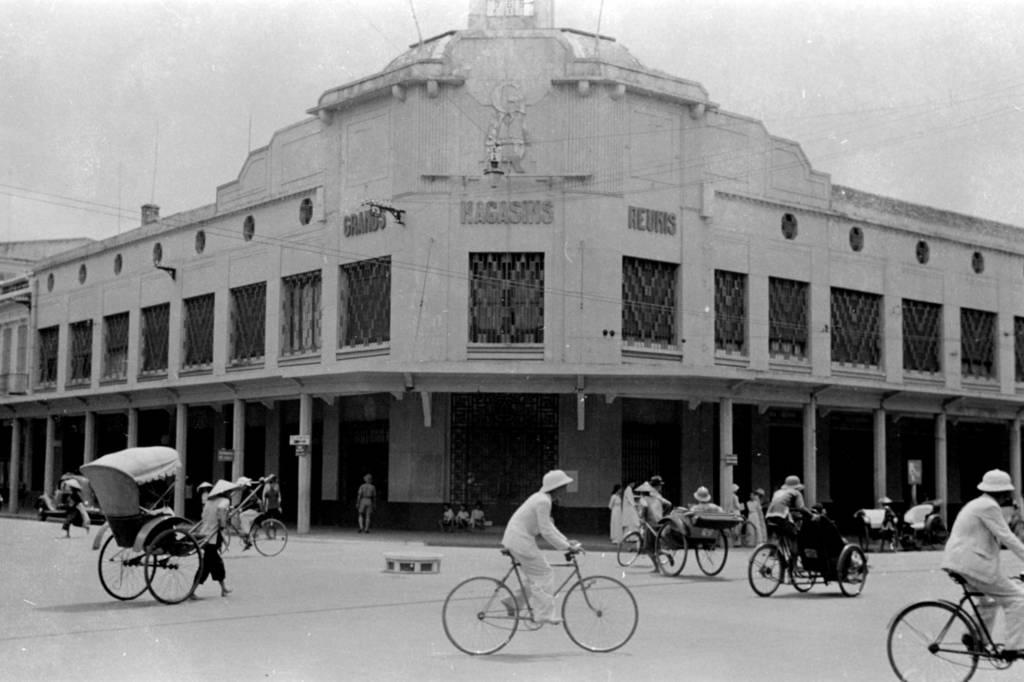What is the man in the image doing? There is a man riding a bicycle in the image. Can you describe another person in the image? There is another man riding a rickshaw in the image. What is a common theme among the people in the image? There are people riding vehicles in the image. What can be seen in the background of the image? There is a building in the background of the image. What type of soup is being served at the coast in the image? There is no soup or coast present in the image; it features two men riding a bicycle and a rickshaw. What idea does the image convey about transportation? The image does not convey a specific idea about transportation, but it shows two different types of vehicles being used. 